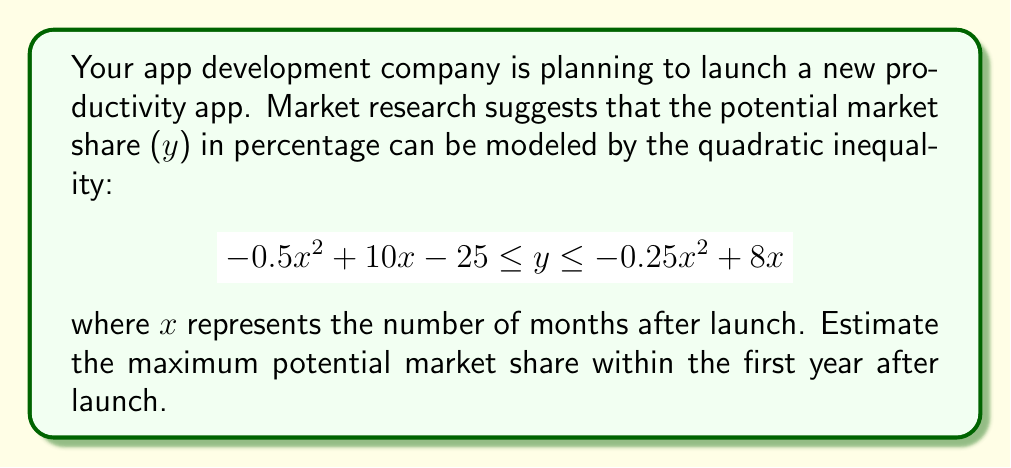Help me with this question. To find the maximum potential market share, we need to:

1. Identify the upper bound of the inequality: $y \leq -0.25x^2 + 8x$
2. Find the vertex of this parabola, which represents the maximum point.
3. Ensure the vertex occurs within the first year (x ≤ 12).

Step 1: The upper bound is $y = -0.25x^2 + 8x$

Step 2: To find the vertex:
a) Use the formula $x = -\frac{b}{2a}$ where $a = -0.25$ and $b = 8$
   $x = -\frac{8}{2(-0.25)} = 16$

b) Calculate y at x = 16:
   $y = -0.25(16)^2 + 8(16) = -64 + 128 = 64$

Step 3: Check if x = 16 is within the first year:
16 > 12, so we need to find the maximum within x ≤ 12.

Step 4: Calculate y when x = 12:
$y = -0.25(12)^2 + 8(12) = -36 + 96 = 60$

Therefore, the maximum potential market share within the first year is 60%.
Answer: 60% 